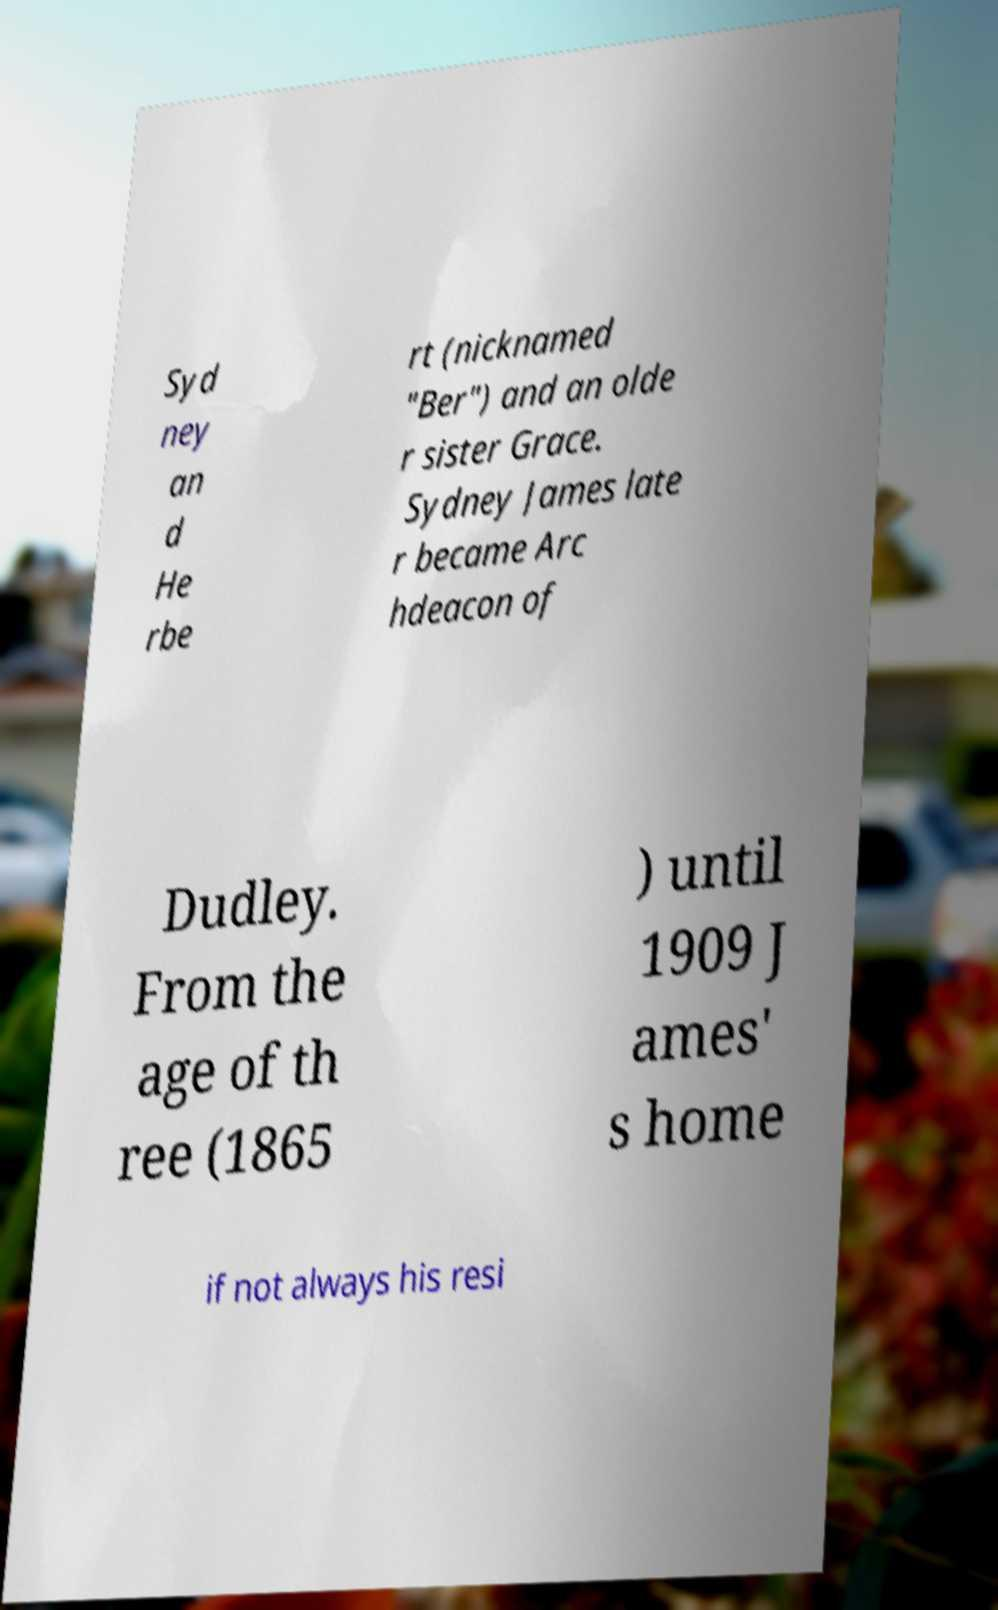Please read and relay the text visible in this image. What does it say? Syd ney an d He rbe rt (nicknamed "Ber") and an olde r sister Grace. Sydney James late r became Arc hdeacon of Dudley. From the age of th ree (1865 ) until 1909 J ames' s home if not always his resi 